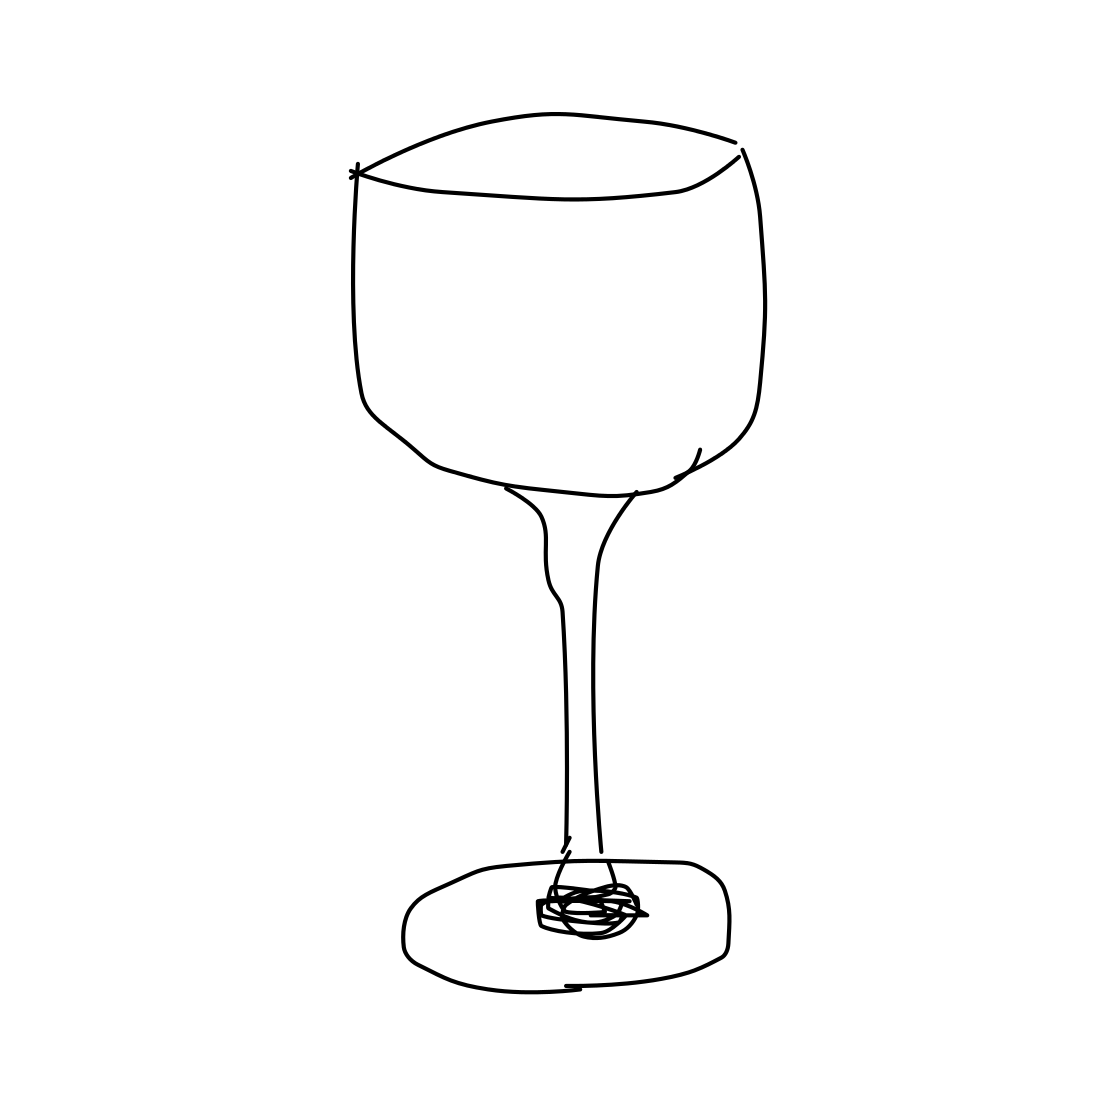What type of wine is this glass designed for? Judging by the broad bowl of the glass in the image, this design is typically used for red wines, which benefit from a larger surface area to allow the wine to breathe and develop its flavors more fully. 